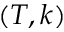Convert formula to latex. <formula><loc_0><loc_0><loc_500><loc_500>( T , k )</formula> 